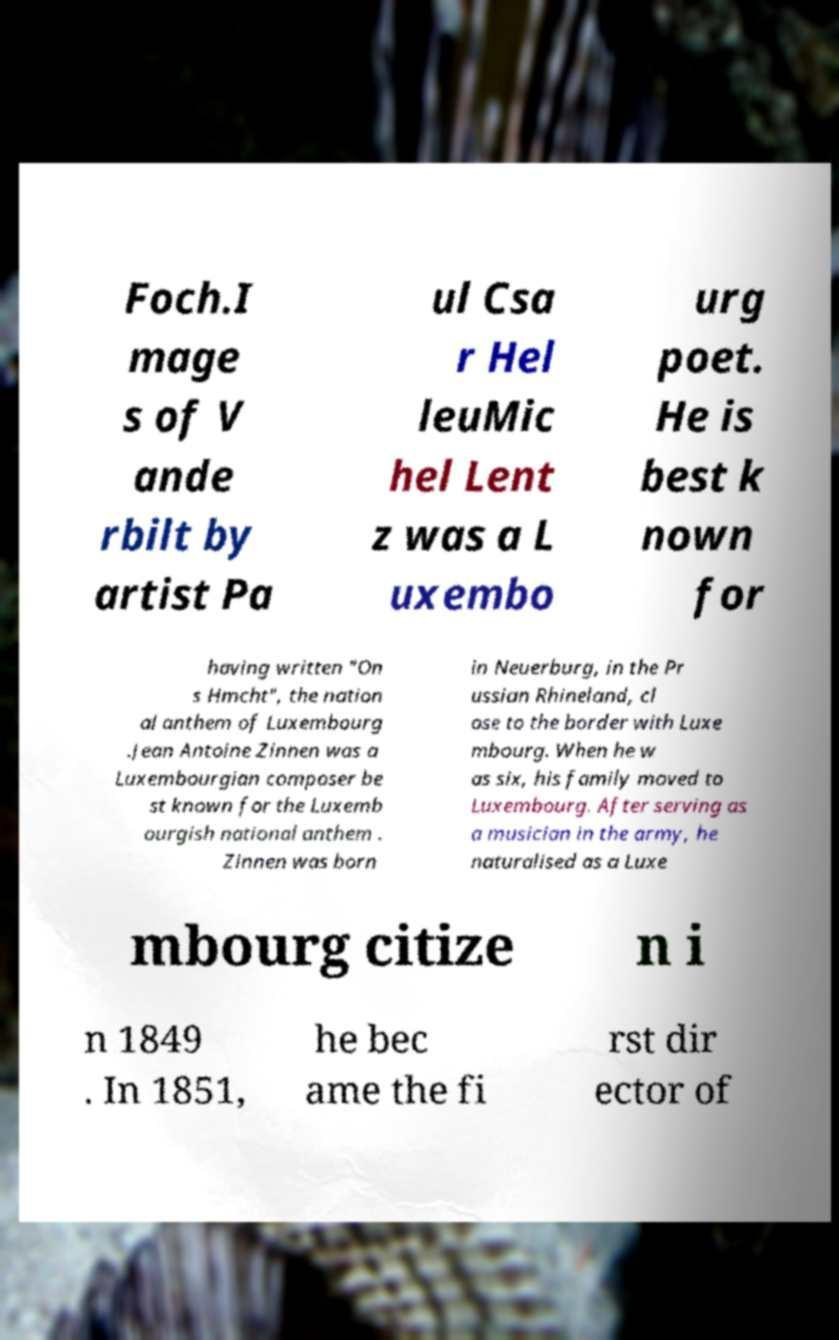Please identify and transcribe the text found in this image. Foch.I mage s of V ande rbilt by artist Pa ul Csa r Hel leuMic hel Lent z was a L uxembo urg poet. He is best k nown for having written "On s Hmcht", the nation al anthem of Luxembourg .Jean Antoine Zinnen was a Luxembourgian composer be st known for the Luxemb ourgish national anthem . Zinnen was born in Neuerburg, in the Pr ussian Rhineland, cl ose to the border with Luxe mbourg. When he w as six, his family moved to Luxembourg. After serving as a musician in the army, he naturalised as a Luxe mbourg citize n i n 1849 . In 1851, he bec ame the fi rst dir ector of 